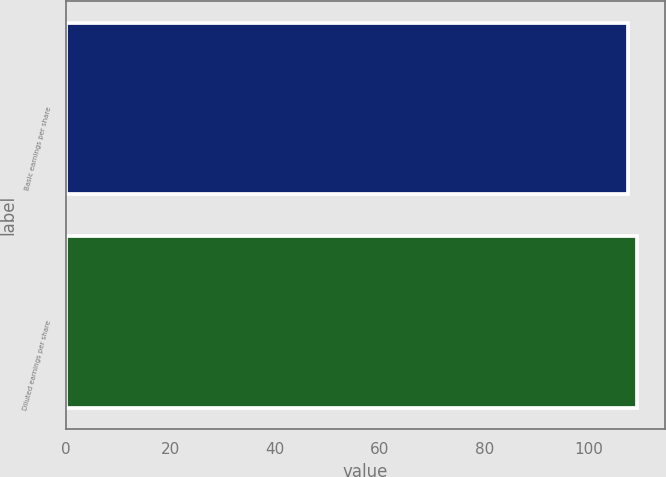Convert chart to OTSL. <chart><loc_0><loc_0><loc_500><loc_500><bar_chart><fcel>Basic earnings per share<fcel>Diluted earnings per share<nl><fcel>107.4<fcel>109.1<nl></chart> 